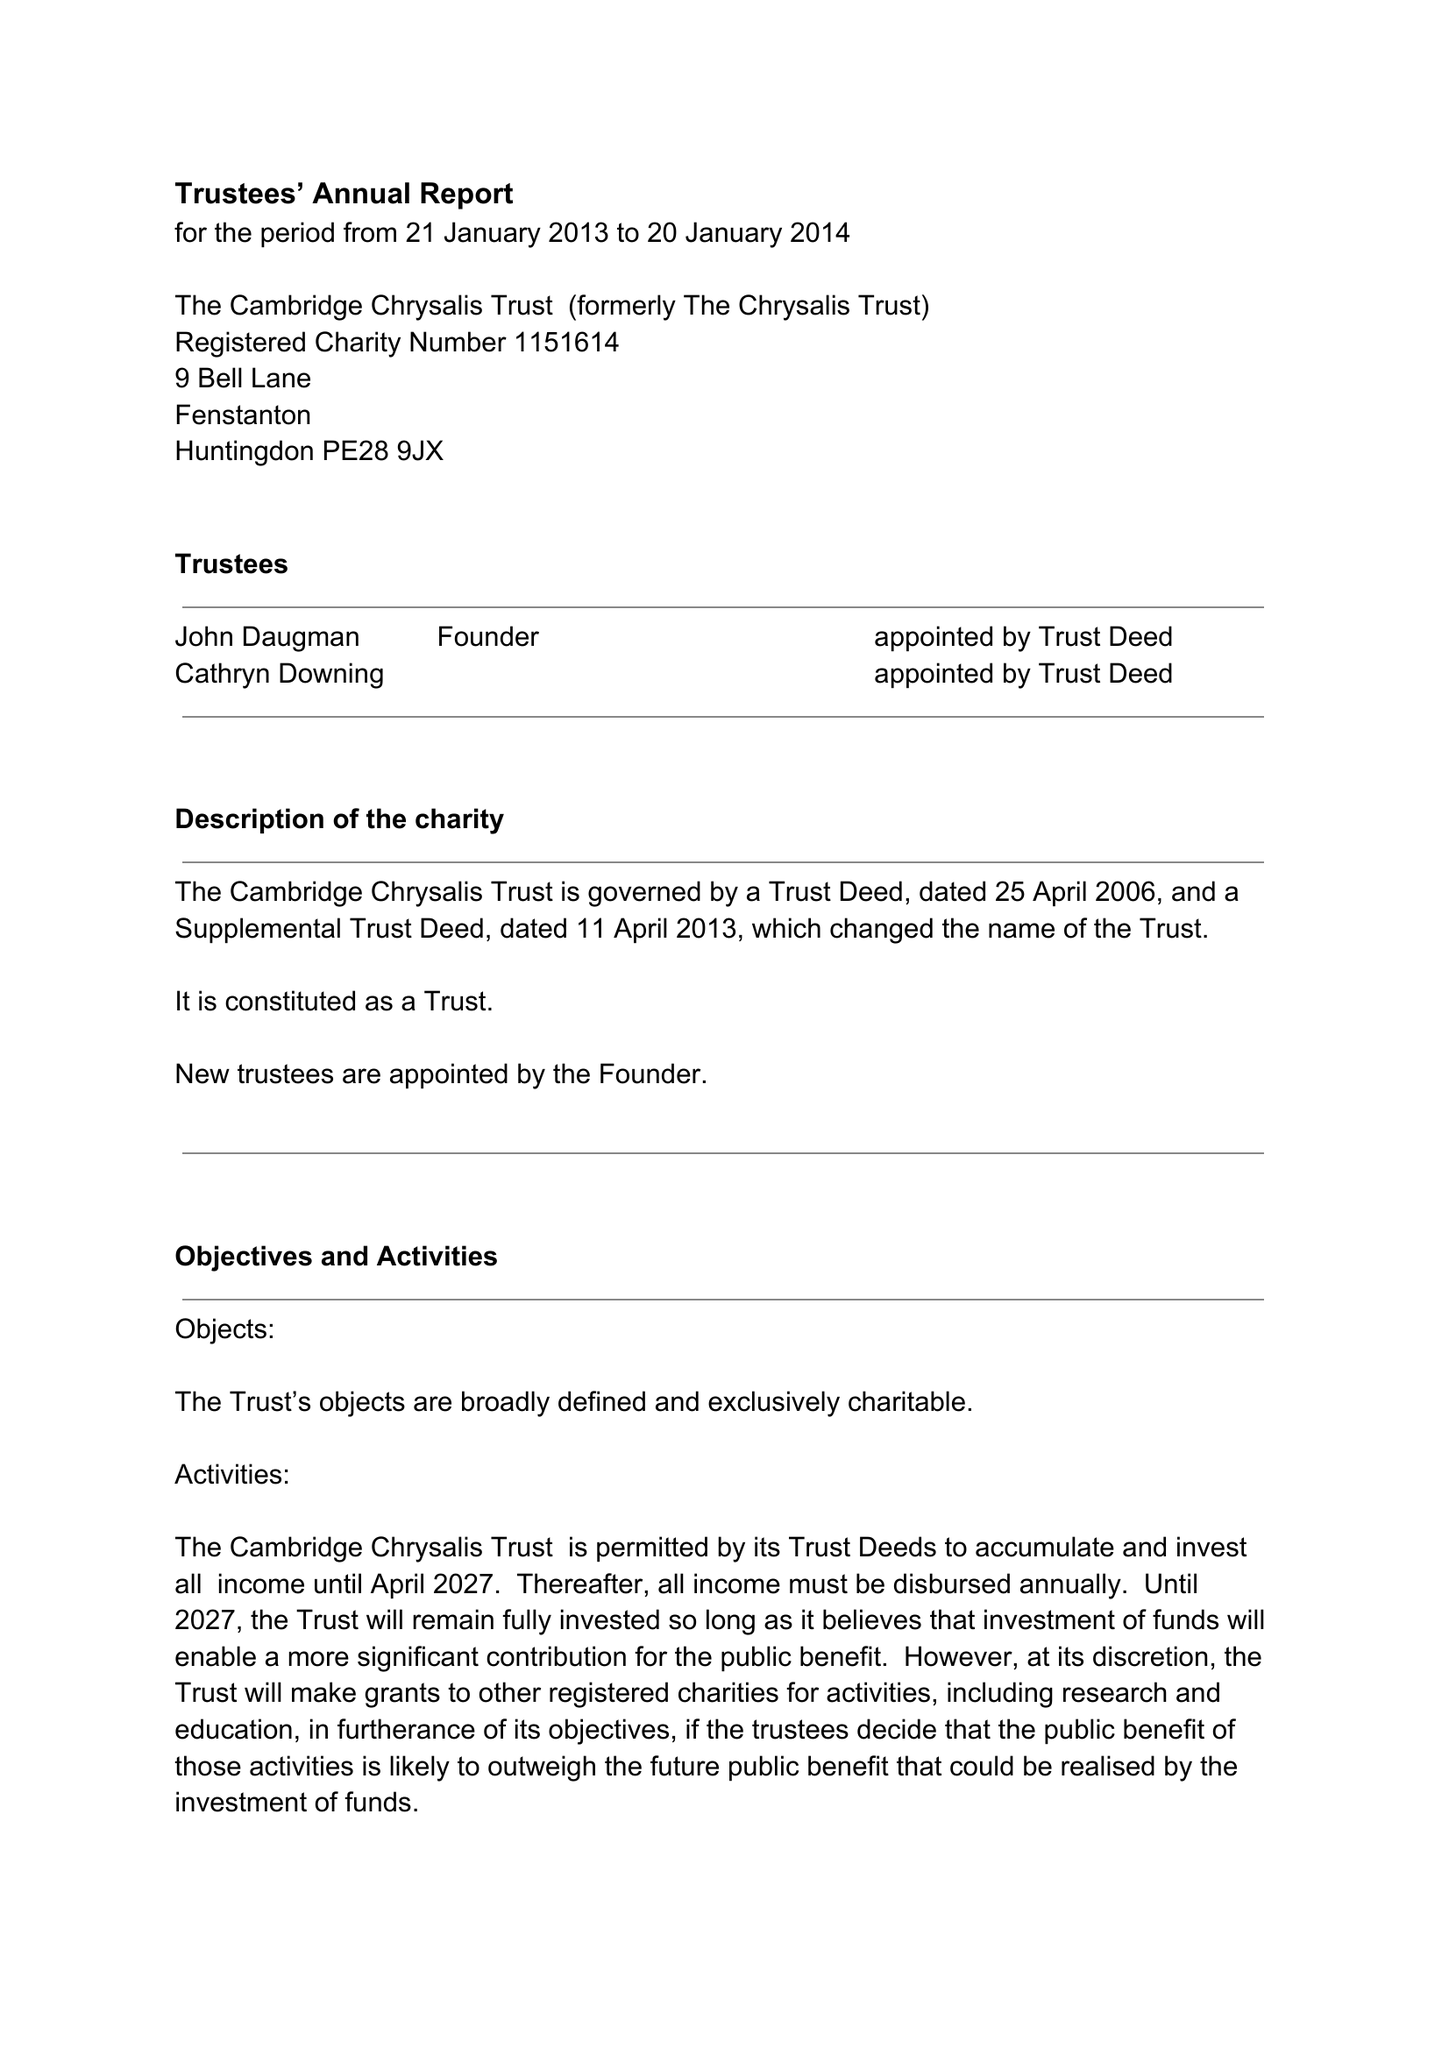What is the value for the address__post_town?
Answer the question using a single word or phrase. HUNTINGDON 